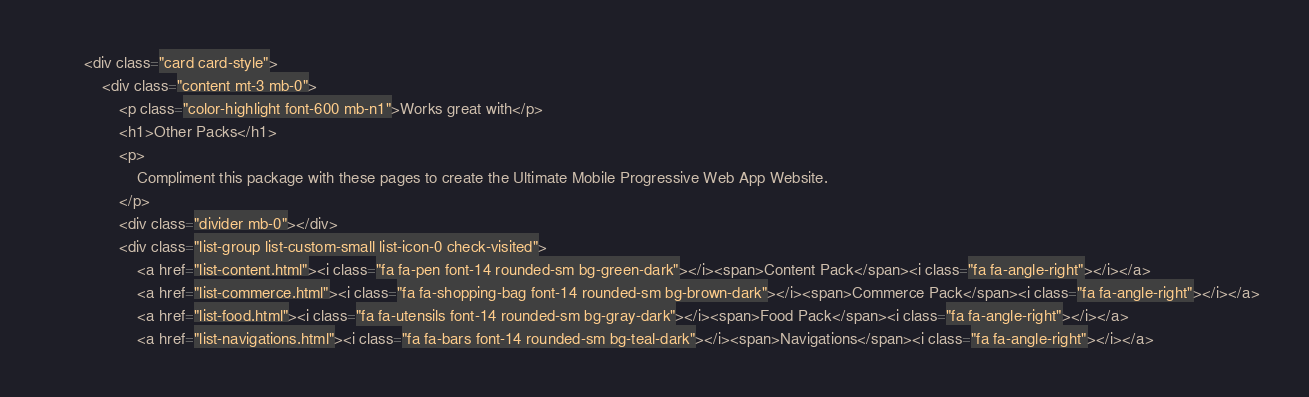Convert code to text. <code><loc_0><loc_0><loc_500><loc_500><_HTML_>        <div class="card card-style">
            <div class="content mt-3 mb-0">
                <p class="color-highlight font-600 mb-n1">Works great with</p>
                <h1>Other Packs</h1>
                <p>
                    Compliment this package with these pages to create the Ultimate Mobile Progressive Web App Website.
                </p>
                <div class="divider mb-0"></div>
                <div class="list-group list-custom-small list-icon-0 check-visited">
                    <a href="list-content.html"><i class="fa fa-pen font-14 rounded-sm bg-green-dark"></i><span>Content Pack</span><i class="fa fa-angle-right"></i></a>
                    <a href="list-commerce.html"><i class="fa fa-shopping-bag font-14 rounded-sm bg-brown-dark"></i><span>Commerce Pack</span><i class="fa fa-angle-right"></i></a>
                    <a href="list-food.html"><i class="fa fa-utensils font-14 rounded-sm bg-gray-dark"></i><span>Food Pack</span><i class="fa fa-angle-right"></i></a>
                    <a href="list-navigations.html"><i class="fa fa-bars font-14 rounded-sm bg-teal-dark"></i><span>Navigations</span><i class="fa fa-angle-right"></i></a></code> 